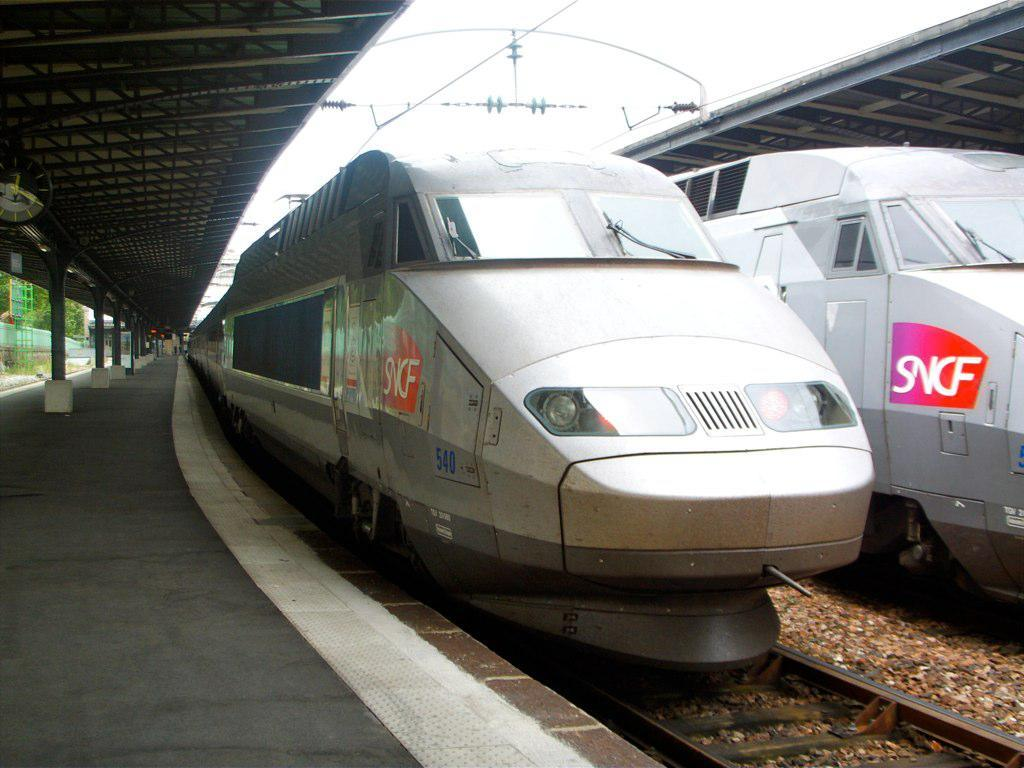<image>
Describe the image concisely. Two trains that say SNCF on them are parked next to each other. 